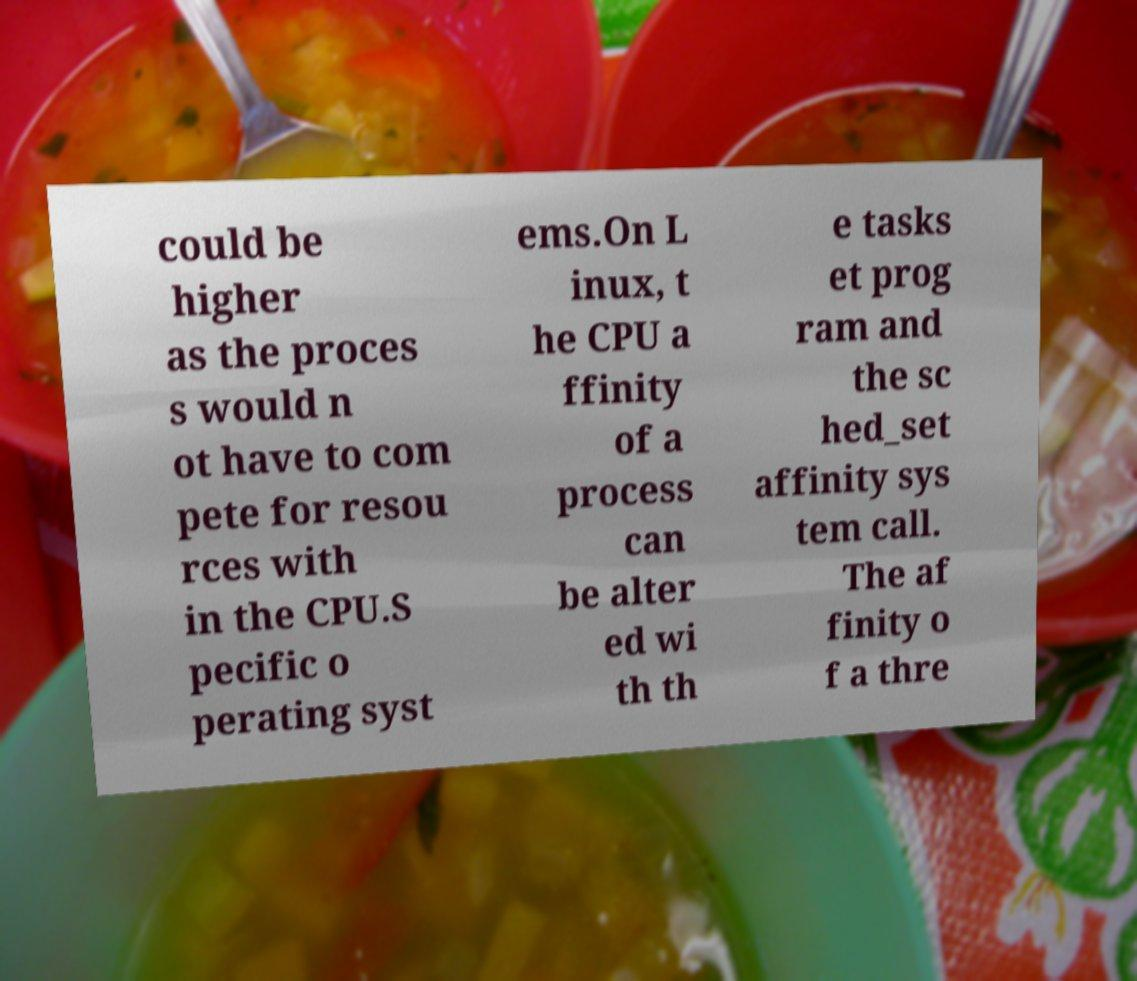Please read and relay the text visible in this image. What does it say? could be higher as the proces s would n ot have to com pete for resou rces with in the CPU.S pecific o perating syst ems.On L inux, t he CPU a ffinity of a process can be alter ed wi th th e tasks et prog ram and the sc hed_set affinity sys tem call. The af finity o f a thre 